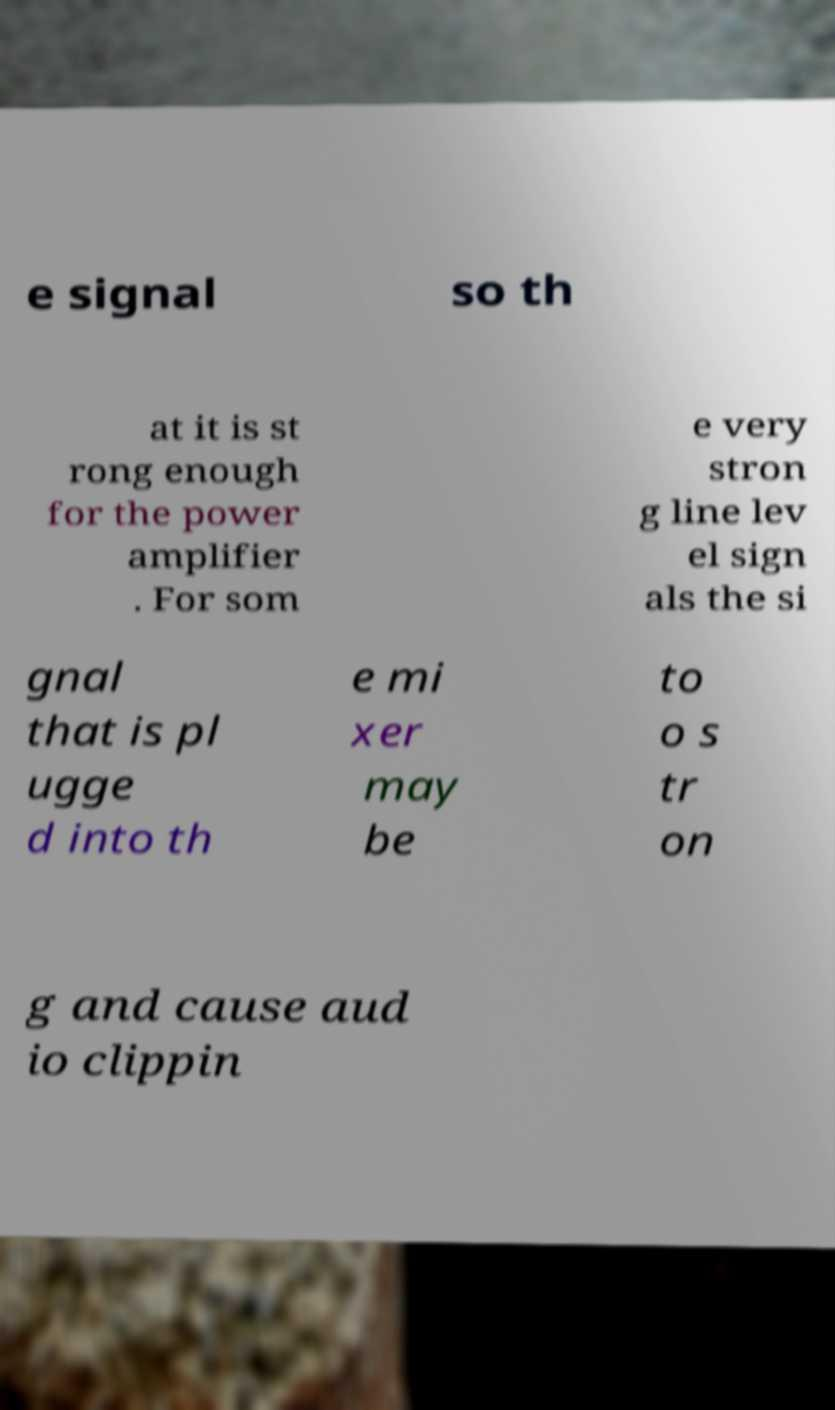Can you read and provide the text displayed in the image?This photo seems to have some interesting text. Can you extract and type it out for me? e signal so th at it is st rong enough for the power amplifier . For som e very stron g line lev el sign als the si gnal that is pl ugge d into th e mi xer may be to o s tr on g and cause aud io clippin 